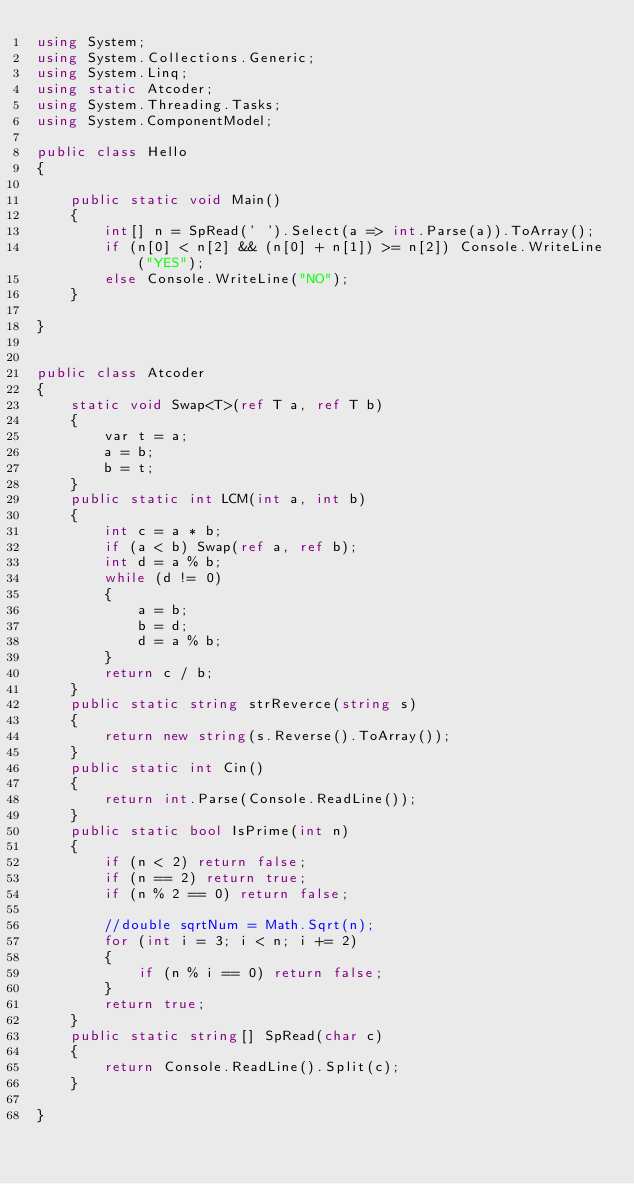<code> <loc_0><loc_0><loc_500><loc_500><_C#_>using System;
using System.Collections.Generic;
using System.Linq;
using static Atcoder;
using System.Threading.Tasks;
using System.ComponentModel;

public class Hello
{

    public static void Main()
    {
        int[] n = SpRead(' ').Select(a => int.Parse(a)).ToArray();
        if (n[0] < n[2] && (n[0] + n[1]) >= n[2]) Console.WriteLine("YES");
        else Console.WriteLine("NO");
    }

}


public class Atcoder
{
    static void Swap<T>(ref T a, ref T b)
    {
        var t = a;
        a = b;
        b = t;
    }
    public static int LCM(int a, int b)
    {
        int c = a * b;
        if (a < b) Swap(ref a, ref b);
        int d = a % b;
        while (d != 0)
        {
            a = b;
            b = d;
            d = a % b;
        }
        return c / b;
    }
    public static string strReverce(string s)
    {
        return new string(s.Reverse().ToArray());
    }
    public static int Cin()
    {
        return int.Parse(Console.ReadLine());
    }
    public static bool IsPrime(int n)
    {
        if (n < 2) return false;
        if (n == 2) return true;
        if (n % 2 == 0) return false;

        //double sqrtNum = Math.Sqrt(n);
        for (int i = 3; i < n; i += 2)
        {
            if (n % i == 0) return false;
        }
        return true;
    }
    public static string[] SpRead(char c)
    {
        return Console.ReadLine().Split(c);
    }

}
</code> 